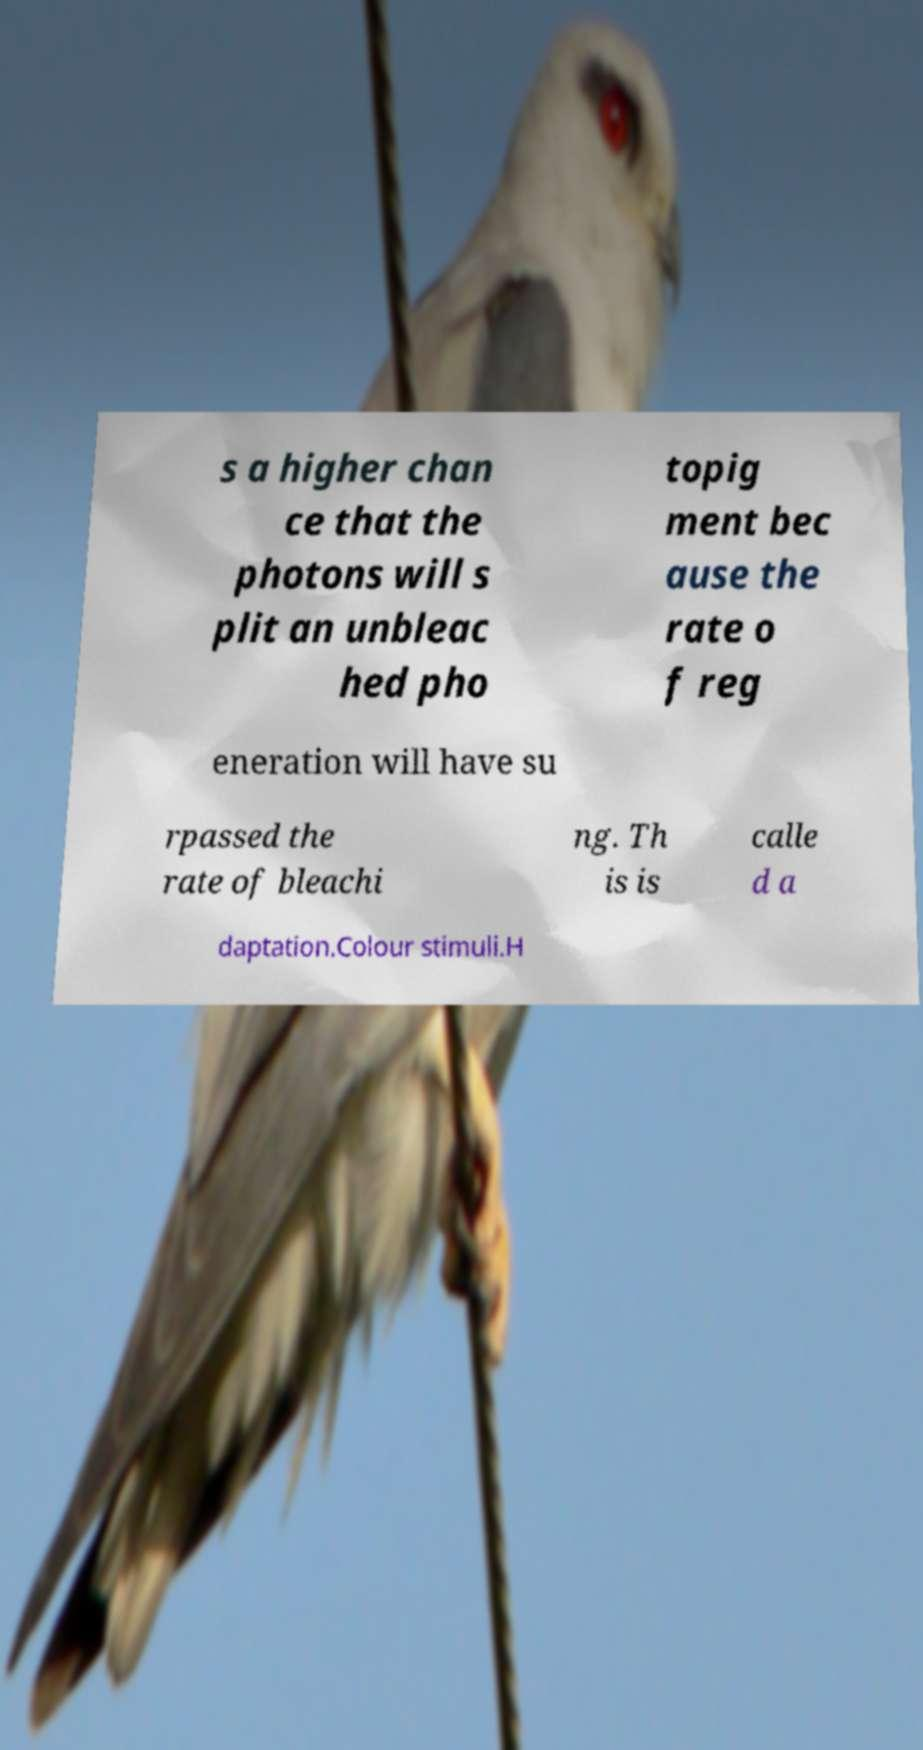I need the written content from this picture converted into text. Can you do that? s a higher chan ce that the photons will s plit an unbleac hed pho topig ment bec ause the rate o f reg eneration will have su rpassed the rate of bleachi ng. Th is is calle d a daptation.Colour stimuli.H 